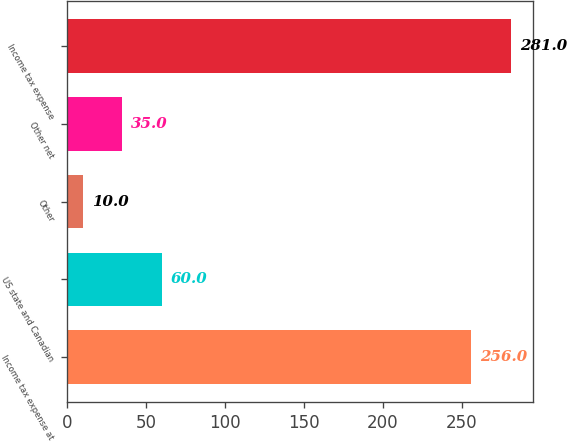<chart> <loc_0><loc_0><loc_500><loc_500><bar_chart><fcel>Income tax expense at<fcel>US state and Canadian<fcel>Other<fcel>Other net<fcel>Income tax expense<nl><fcel>256<fcel>60<fcel>10<fcel>35<fcel>281<nl></chart> 